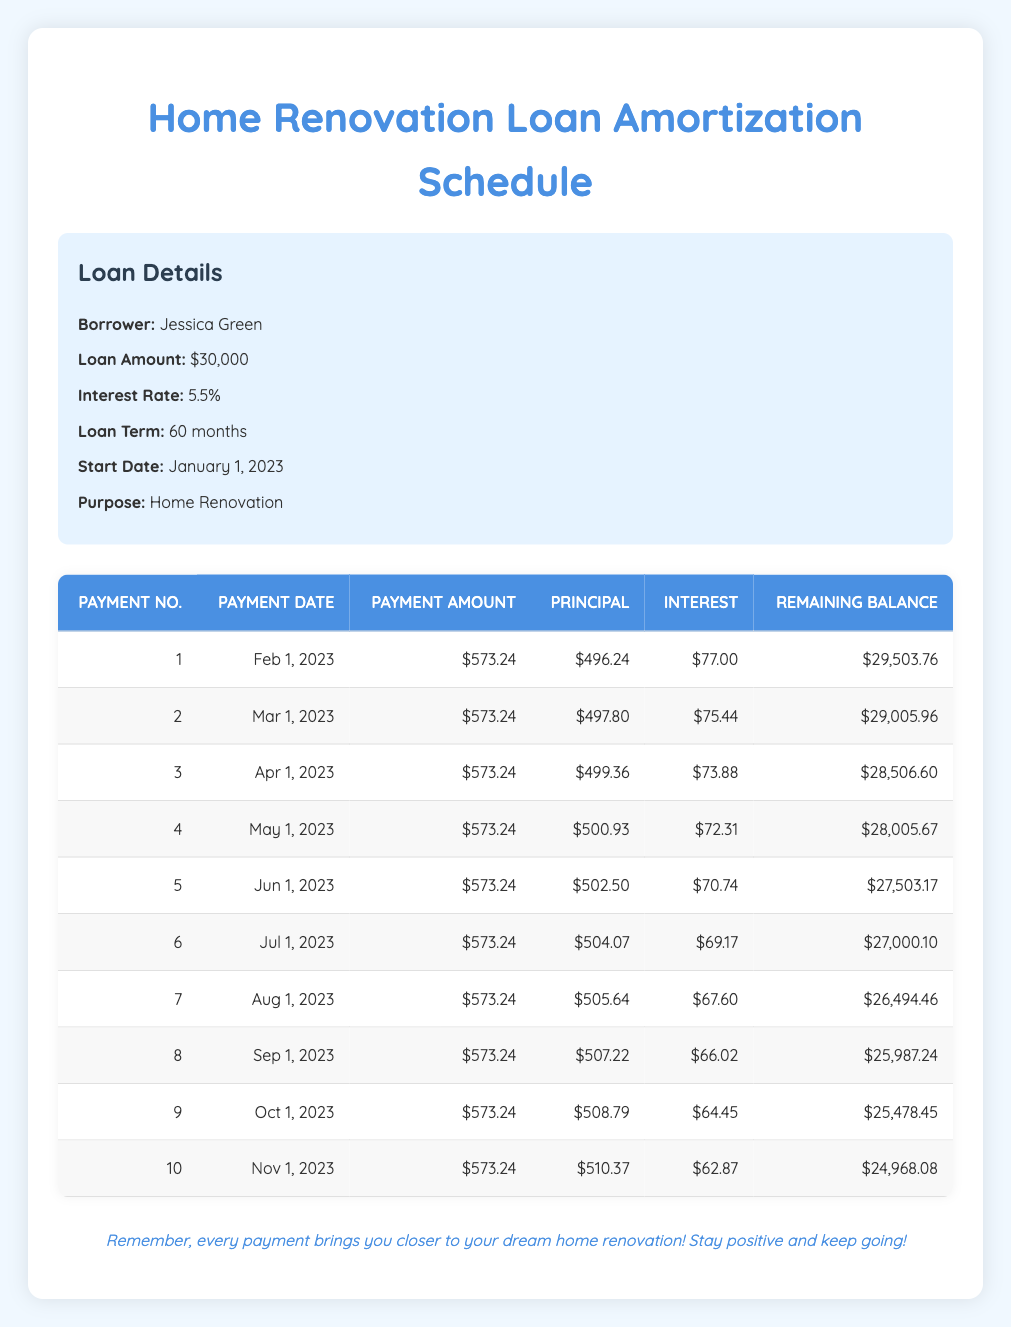What is the total amount of interest paid after the first three payments? To find the total interest paid after the first three payments, we need to add the interest amounts from the first three rows: 77.00 (first payment) + 75.44 (second payment) + 73.88 (third payment) = 226.32.
Answer: 226.32 What is the remaining balance after the fifth payment? The remaining balance after the fifth payment can be found in the fifth row of the table, which shows a balance of 27,503.17.
Answer: 27,503.17 Is the payment amount consistent for the first ten payments? All the payment amounts in the first ten rows are the same at $573.24, indicating that the payment is consistent.
Answer: Yes What is the difference in the principal amount paid between the first and the last payment in the first ten payments? The principal amount for the first payment is 496.24, and for the last (tenth) payment, it is 510.37. The difference is calculated as 510.37 - 496.24 = 14.13.
Answer: 14.13 What is the average principal amount paid over the first ten payments? To find the average, first sum the principal amounts: 496.24 + 497.80 + 499.36 + 500.93 + 502.50 + 504.07 + 505.64 + 507.22 + 508.79 + 510.37 = 5,532.92. Then divide this by 10 (the number of payments): 5,532.92 / 10 = 553.29.
Answer: 553.29 What is the smallest interest amount paid in the first ten payments? We look at the interest amounts in the table for the first ten payments: 77.00, 75.44, 73.88, 72.31, 70.74, 69.17, 67.60, 66.02, 64.45, 62.87. The smallest value is 62.87 (the tenth payment).
Answer: 62.87 What is the total payment amount made after the first four payments? To find the total payment amount after the first four payments, multiply the payment amount of $573.24 by the number of payments: 573.24 * 4 = 2,293.00.
Answer: 2,293.00 Is the principal amount increasing with each payment? By reviewing the principal amounts across the first ten payments, we see they are increasing: 496.24, 497.80, 499.36, 500.93, 502.50, etc., confirming that the principal amount is indeed increasing.
Answer: Yes 